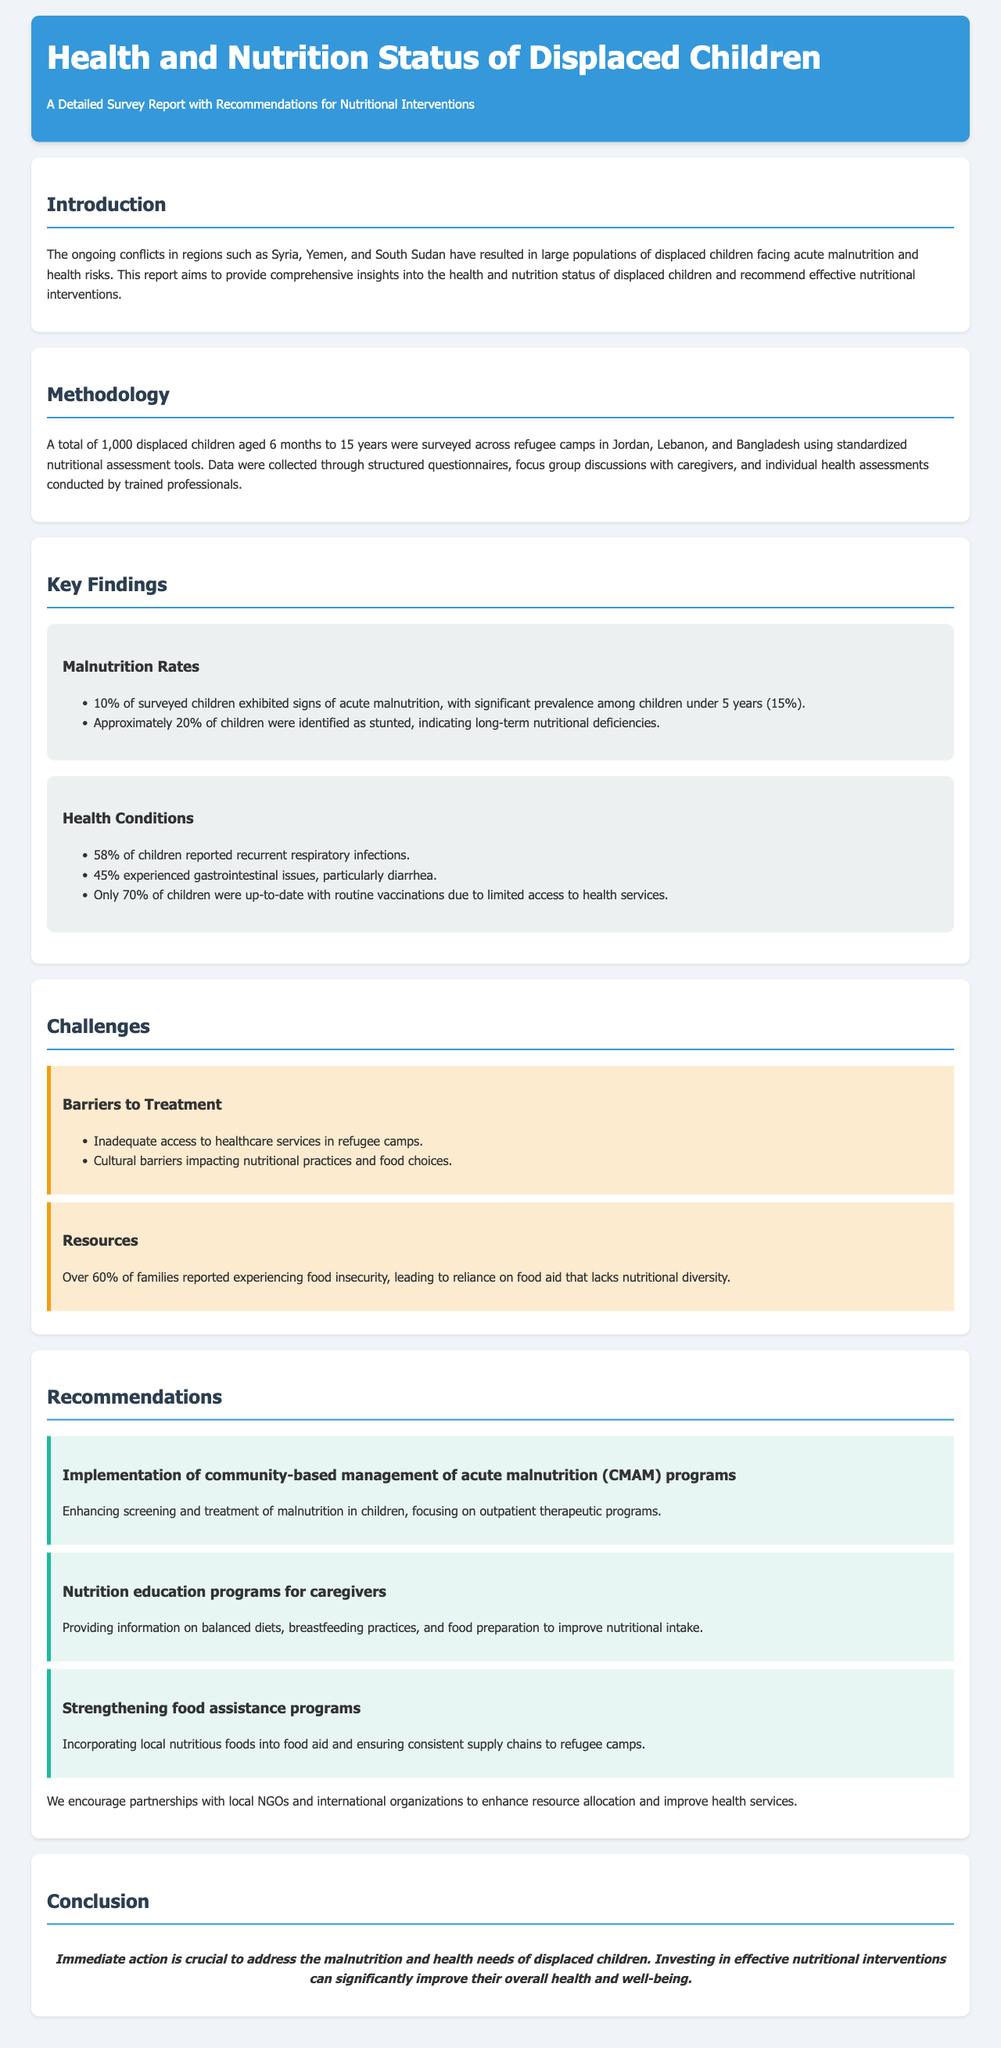What percentage of surveyed children exhibited signs of acute malnutrition? The document states that 10% of surveyed children exhibited signs of acute malnutrition.
Answer: 10% What age group had a significant prevalence of acute malnutrition? The document mentions that there is a significant prevalence of acute malnutrition among children under 5 years.
Answer: Children under 5 years What percentage of children reported recurrent respiratory infections? According to the document, 58% of children reported recurrent respiratory infections.
Answer: 58% What barriers to treatment are mentioned in the challenges section? The report highlights inadequate access to healthcare services and cultural barriers impacting nutritional practices as barriers to treatment.
Answer: Inadequate access to healthcare services; cultural barriers What are the healthcare needs of displaced children summarized in the conclusion? The conclusion indicates the need for immediate action to address malnutrition and health needs of displaced children.
Answer: Immediate action What is one recommendation for improving nutritional intervention? The report recommends the implementation of community-based management of acute malnutrition (CMAM) programs as a solution.
Answer: Community-based management of acute malnutrition (CMAM) programs 